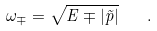Convert formula to latex. <formula><loc_0><loc_0><loc_500><loc_500>\omega _ { \mp } = \sqrt { E \mp | \vec { p } | } \quad .</formula> 